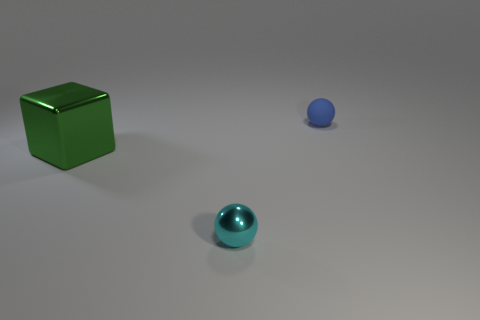Do the blue matte thing and the small object in front of the tiny matte ball have the same shape?
Provide a succinct answer. Yes. What is the blue ball made of?
Your answer should be compact. Rubber. The small ball right of the sphere in front of the thing behind the large green block is what color?
Give a very brief answer. Blue. What is the material of the tiny cyan object that is the same shape as the blue rubber thing?
Give a very brief answer. Metal. What number of shiny objects are the same size as the rubber sphere?
Provide a succinct answer. 1. How many blue matte things are there?
Ensure brevity in your answer.  1. Are the green cube and the small object behind the large green shiny block made of the same material?
Your response must be concise. No. How many green objects are cubes or tiny matte spheres?
Your response must be concise. 1. There is a block that is made of the same material as the small cyan ball; what is its size?
Your answer should be compact. Large. What number of large shiny things have the same shape as the tiny matte object?
Ensure brevity in your answer.  0. 